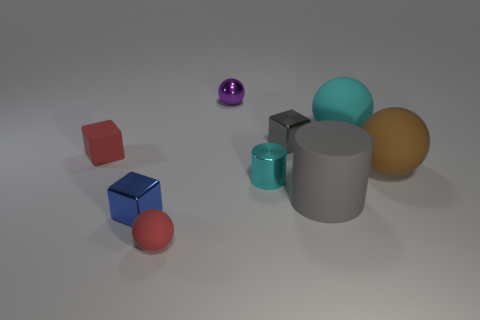Subtract all gray cylinders. How many cylinders are left? 1 Subtract all gray cubes. How many cubes are left? 2 Subtract 1 cylinders. How many cylinders are left? 1 Subtract all spheres. How many objects are left? 5 Subtract all brown cubes. How many yellow cylinders are left? 0 Add 4 small cylinders. How many small cylinders exist? 5 Subtract 0 purple cylinders. How many objects are left? 9 Subtract all green cubes. Subtract all purple balls. How many cubes are left? 3 Subtract all purple balls. Subtract all large cyan rubber things. How many objects are left? 7 Add 6 balls. How many balls are left? 10 